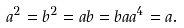<formula> <loc_0><loc_0><loc_500><loc_500>a ^ { 2 } = b ^ { 2 } = a b = b a a ^ { 4 } = a .</formula> 